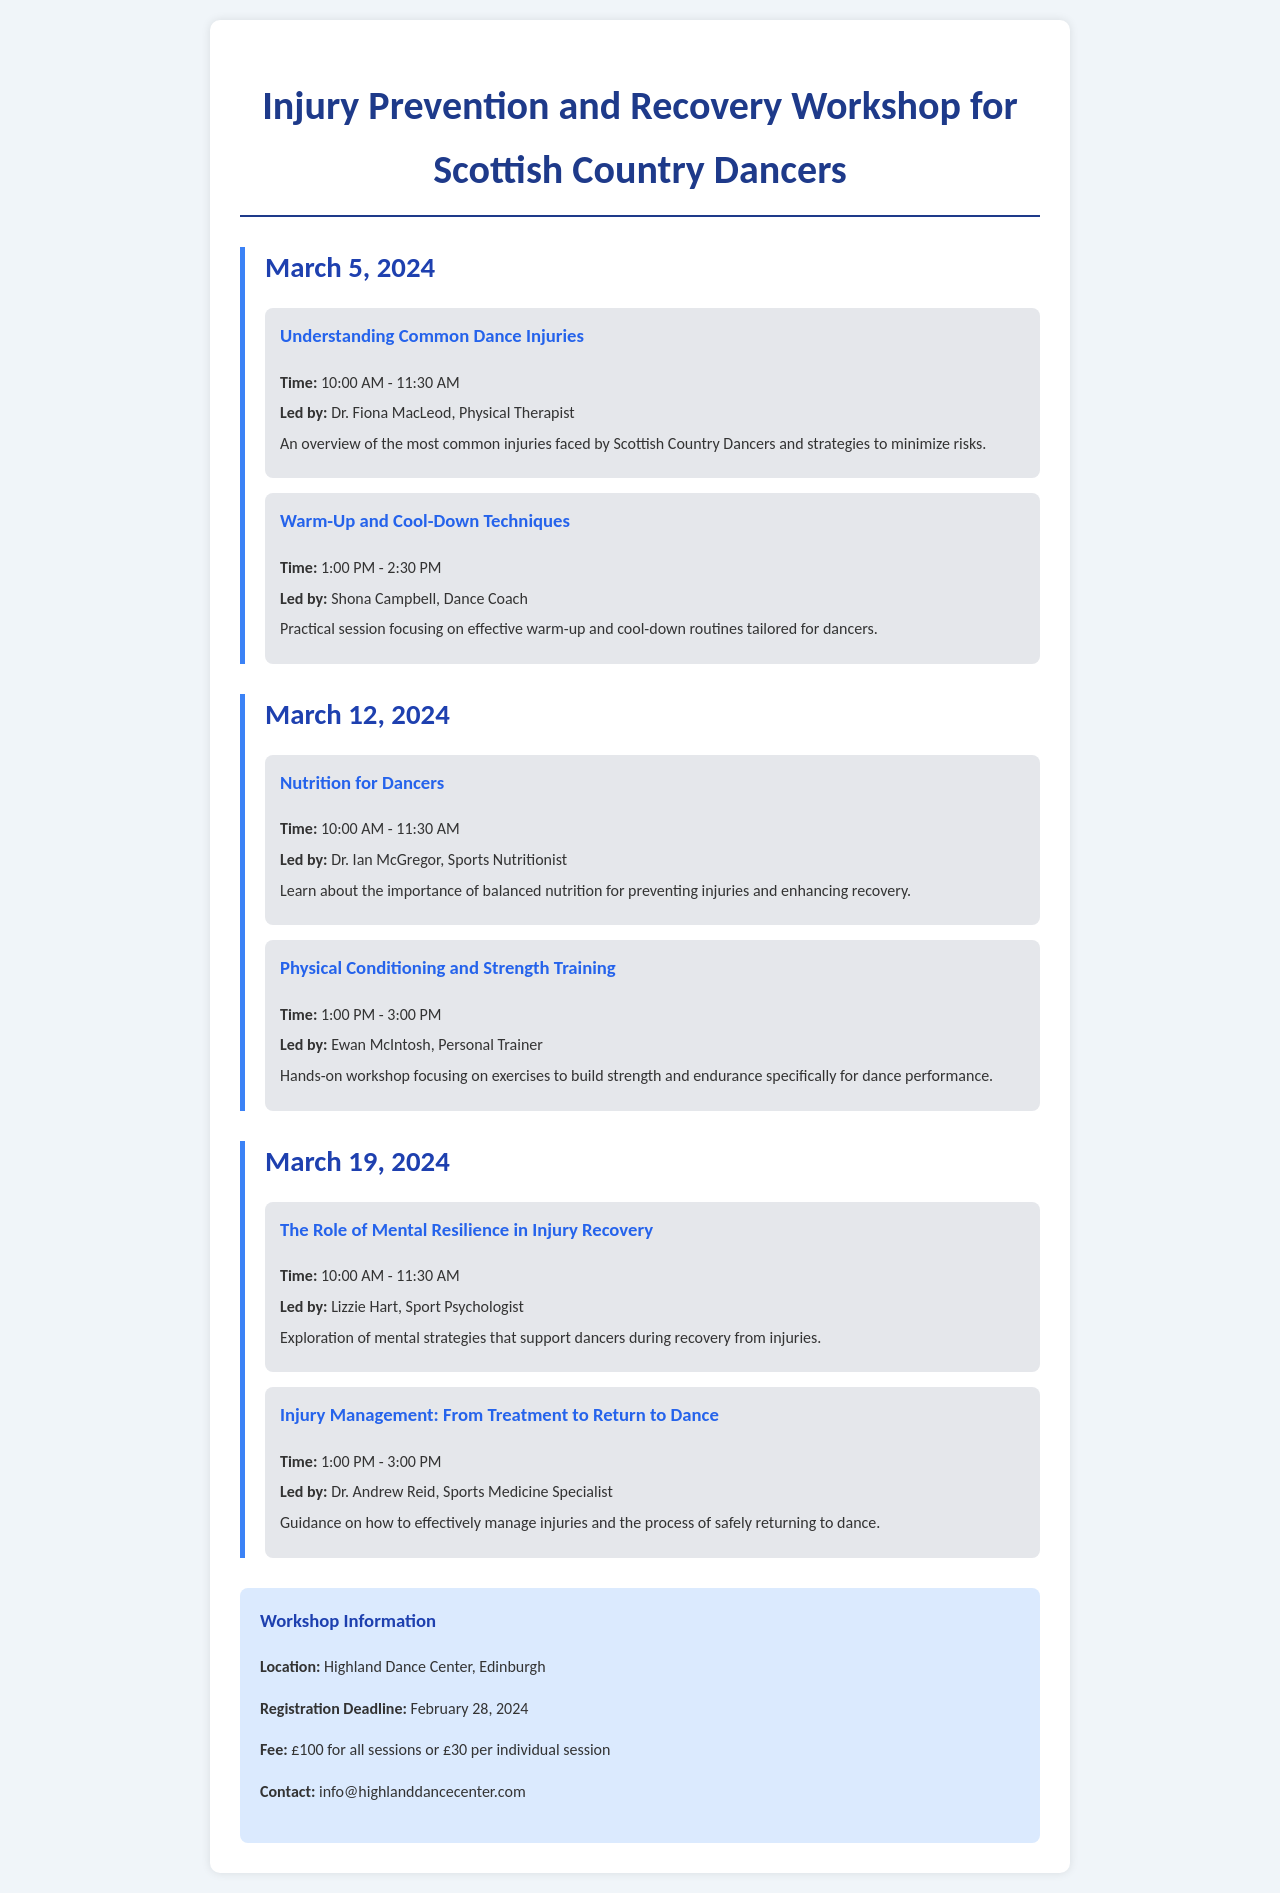what is the title of the workshop? The title of the workshop is provided at the beginning of the document.
Answer: Injury Prevention and Recovery Workshop for Scottish Country Dancers when is the registration deadline? The registration deadline is mentioned in the workshop information section.
Answer: February 28, 2024 who is leading the session on Nutrition for Dancers? The leader of the session is listed with the session details.
Answer: Dr. Ian McGregor how many sessions are scheduled on March 12, 2024? The number of sessions on each date is counted from the document.
Answer: 2 what is the duration of the session "Injury Management: From Treatment to Return to Dance"? The duration is found in the session details.
Answer: 2 hours what is the location of the workshop? The location is clearly stated in the workshop information section.
Answer: Highland Dance Center, Edinburgh which session focuses on mental strategies? The session is identified by its title provided in the schedule.
Answer: The Role of Mental Resilience in Injury Recovery how much does it cost to attend all sessions? The fee for all sessions is provided in the workshop information.
Answer: £100 who is the physical therapist leading the first session? The leader of the first session is listed with the session details.
Answer: Dr. Fiona MacLeod 